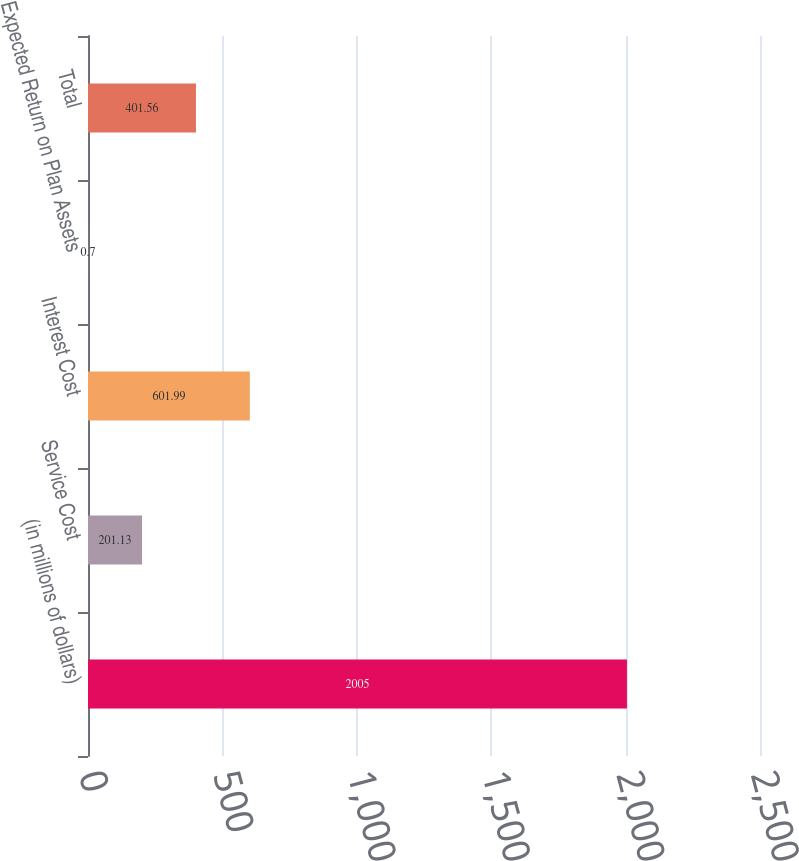Convert chart to OTSL. <chart><loc_0><loc_0><loc_500><loc_500><bar_chart><fcel>(in millions of dollars)<fcel>Service Cost<fcel>Interest Cost<fcel>Expected Return on Plan Assets<fcel>Total<nl><fcel>2005<fcel>201.13<fcel>601.99<fcel>0.7<fcel>401.56<nl></chart> 